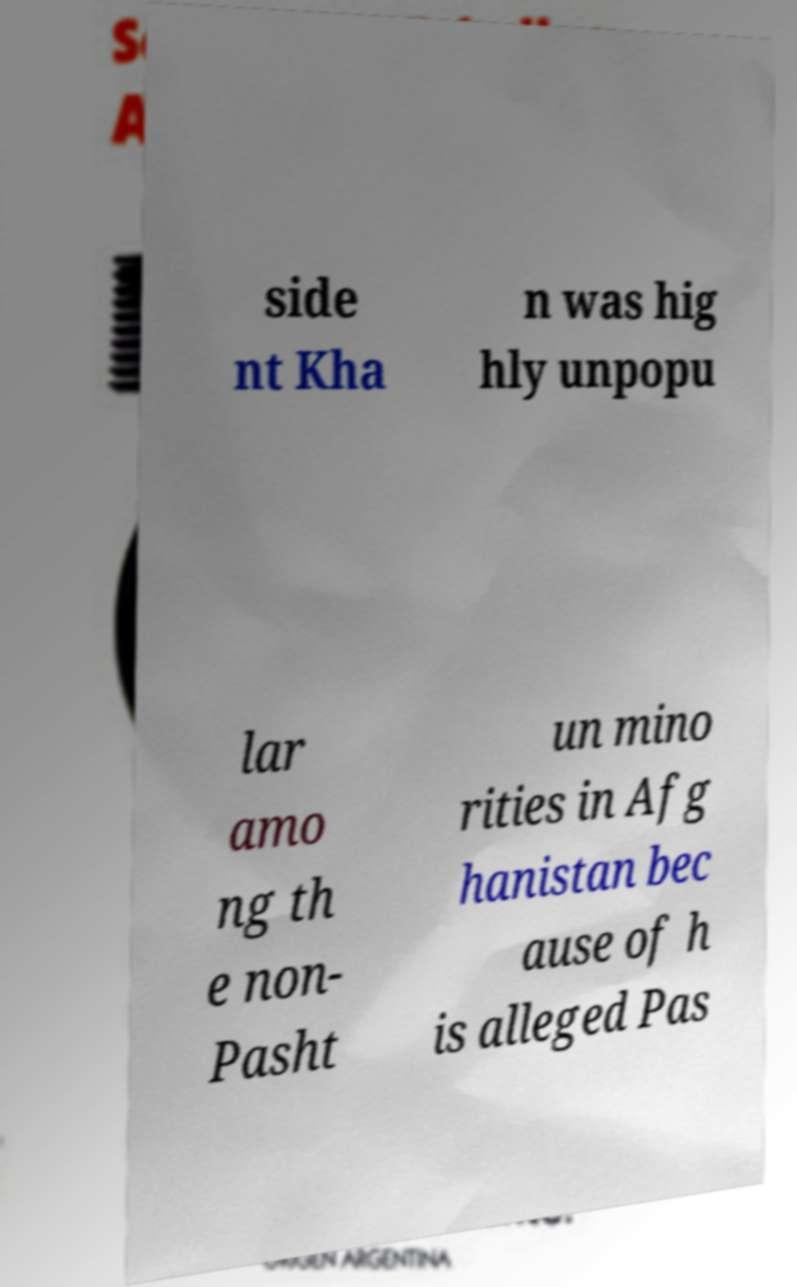Can you accurately transcribe the text from the provided image for me? side nt Kha n was hig hly unpopu lar amo ng th e non- Pasht un mino rities in Afg hanistan bec ause of h is alleged Pas 